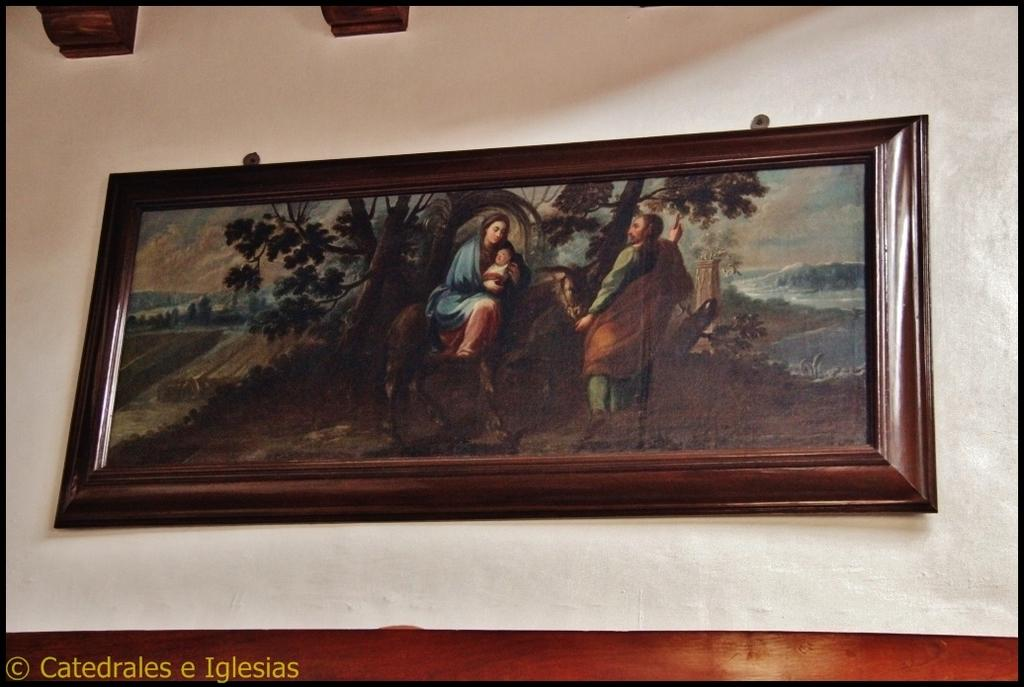What is on the wall in the image? There is a frame on the wall in the image. What is inside the frame? The frame contains a picture with people, a horse, trees, and hills. Is there any text or label on the image? Yes, there is a name in the left bottom corner of the image. What type of spark can be seen coming from the horse's mouth in the image? There is no spark coming from the horse's mouth in the image; it is a still picture. Is there a gun visible in the image? No, there is no gun present in the image. 